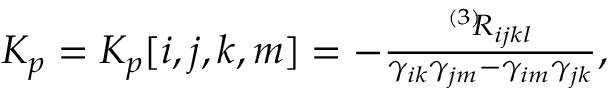Convert formula to latex. <formula><loc_0><loc_0><loc_500><loc_500>\begin{array} { r } { K _ { p } = K _ { p } [ i , j , k , m ] = - \frac { ^ { \left ( 3 \right ) } \, R _ { i j k l } } { \gamma _ { i k } \gamma _ { j m } - \gamma _ { i m } \gamma _ { j k } } , } \end{array}</formula> 